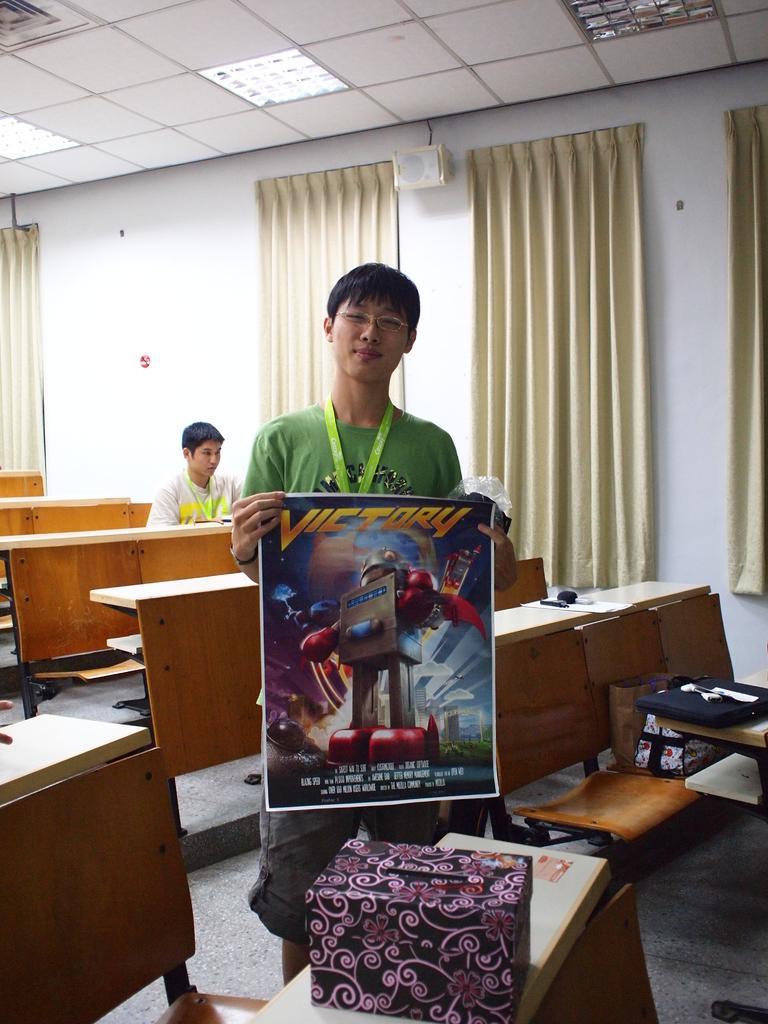Can you describe this image briefly? In this image there are some tables on one table there a box and a man holding a poster in the background there are some curtains which are in cream color. 